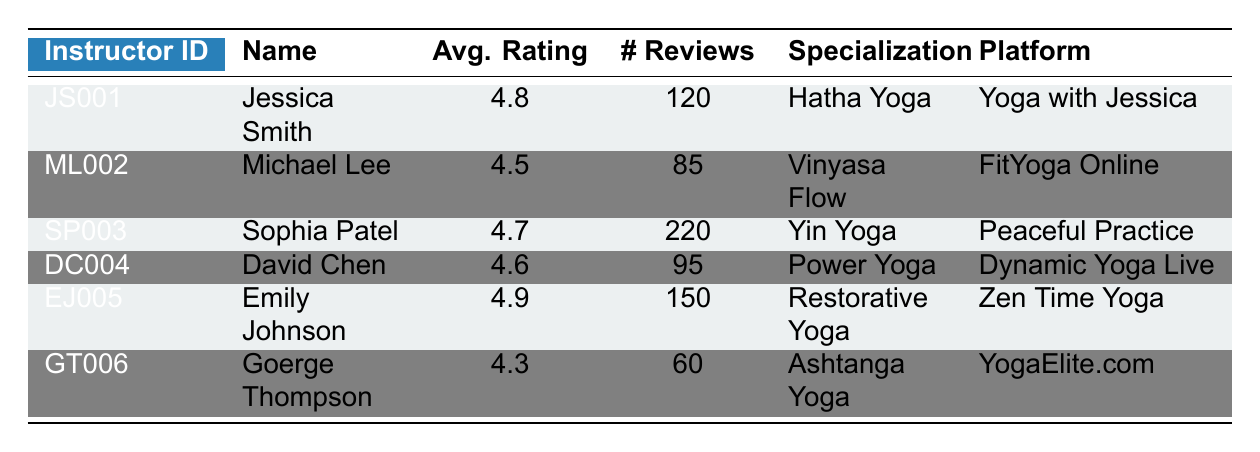What is the average rating of Jessica Smith? Jessica Smith's average rating is directly listed in the table under the "Avg. Rating" column. It shows 4.8.
Answer: 4.8 How many reviews did Sophia Patel receive? The number of reviews for Sophia Patel is found in the "Number of Reviews" column corresponding to her row. It indicates 220 reviews.
Answer: 220 Is Emily Johnson's average rating higher than Michael Lee's? Emily Johnson's average rating is 4.9 while Michael Lee's is 4.5. Since 4.9 is greater than 4.5, the answer is yes.
Answer: Yes What yoga specialization does David Chen teach? The table provides the specialization for each instructor. For David Chen, his specialization is listed as "Power Yoga."
Answer: Power Yoga What is the total number of reviews from all instructors? To find the total number of reviews, sum up each instructor's number of reviews: 120 + 85 + 220 + 95 + 150 + 60 = 730.
Answer: 730 Which instructor has the highest average rating and how much is it? The highest average rating can be identified by comparing the "Avg. Rating" column. Emily Johnson has the highest rating of 4.9.
Answer: 4.9 Is there any instructor who specializes in Ashtanga Yoga? The table shows that George Thompson specializes in Ashtanga Yoga, so the answer is yes.
Answer: Yes What is the difference in average ratings between the highest and lowest ranked instructors? Emily Johnson has the highest average rating of 4.9, and George Thompson has the lowest with a 4.3. The difference is 4.9 - 4.3 = 0.6.
Answer: 0.6 How many more reviews does Sophia Patel have compared to George Thompson? Sophia Patel has 220 reviews and George Thompson has 60. The difference is 220 - 60 = 160 more reviews for Sophia Patel.
Answer: 160 